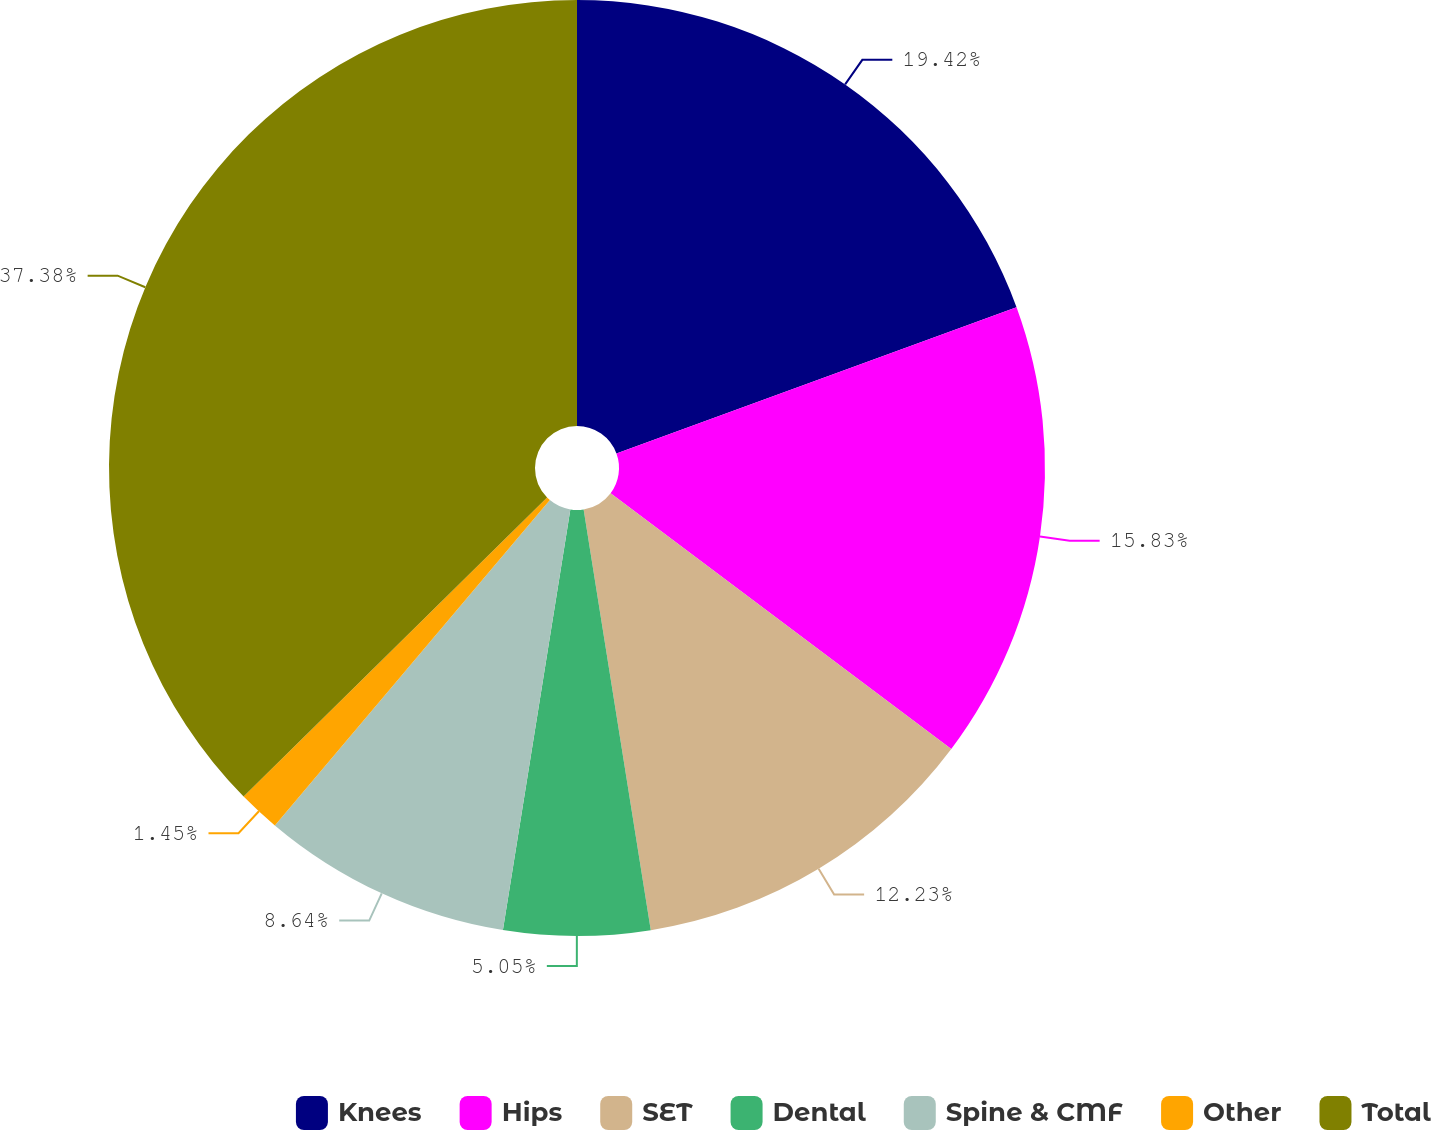<chart> <loc_0><loc_0><loc_500><loc_500><pie_chart><fcel>Knees<fcel>Hips<fcel>SET<fcel>Dental<fcel>Spine & CMF<fcel>Other<fcel>Total<nl><fcel>19.42%<fcel>15.83%<fcel>12.23%<fcel>5.05%<fcel>8.64%<fcel>1.45%<fcel>37.38%<nl></chart> 